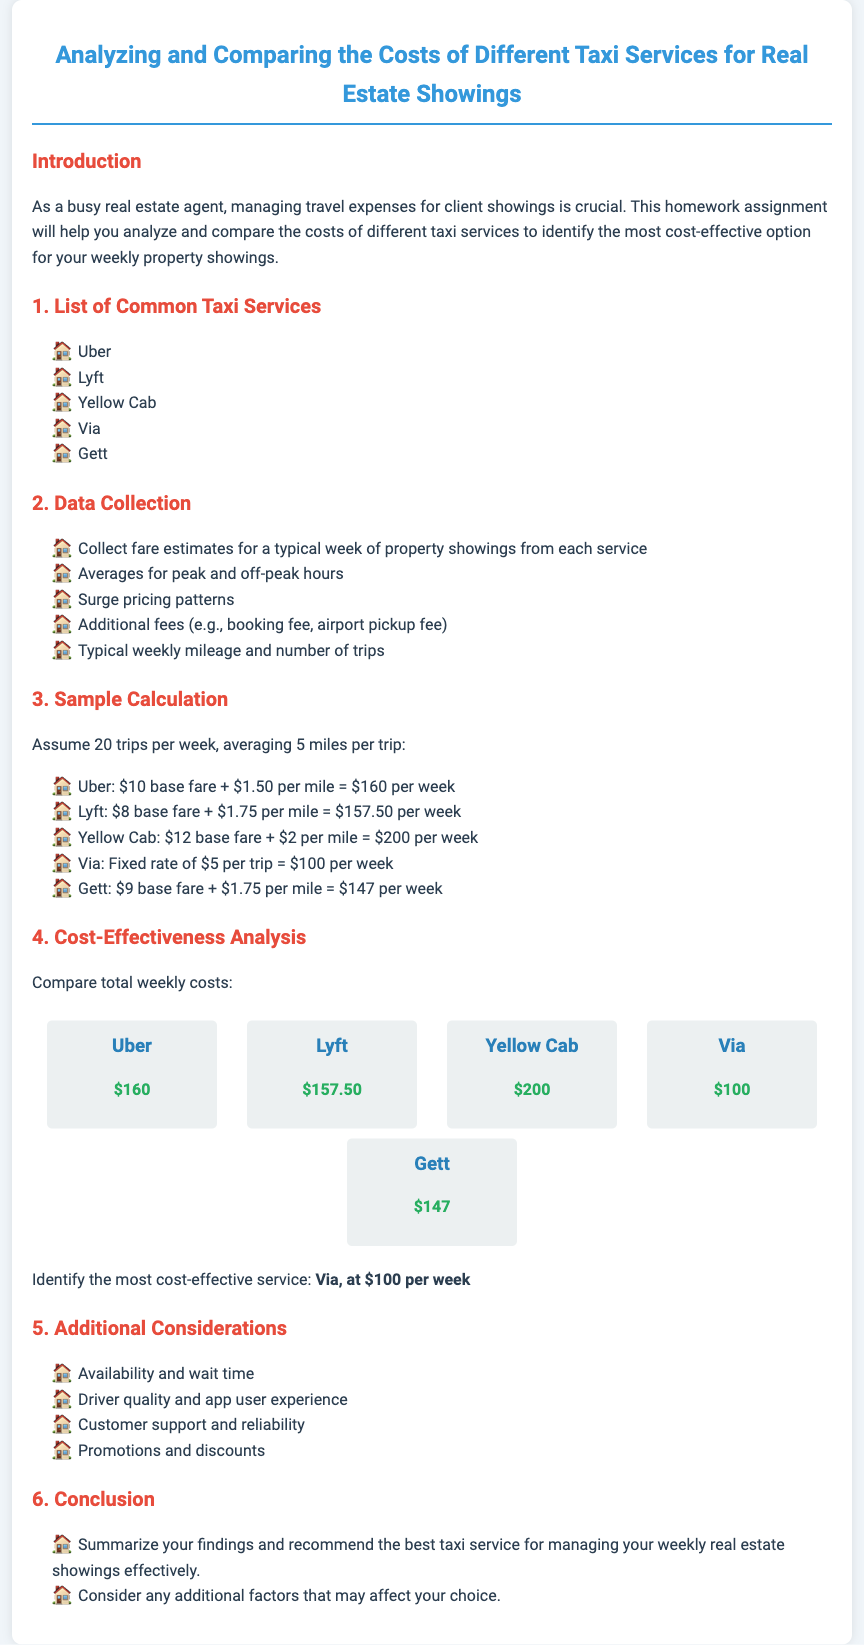what is the total cost for Uber per week? The document states that the total weekly cost for Uber is $160.
Answer: $160 which taxi service has the highest weekly cost? The cost comparison section shows that Yellow Cab has the highest weekly cost at $200.
Answer: Yellow Cab what is the fixed rate per trip for Via? The document specifies that Via has a fixed rate of $5 per trip.
Answer: $5 which service is identified as the most cost-effective option? The conclusion identifies Via as the most cost-effective service at $100 per week.
Answer: Via how many trips per week are assumed for the calculations? The sample calculation section indicates an assumption of 20 trips per week.
Answer: 20 what is the base fare for Lyft? The document states that the base fare for Lyft is $8.
Answer: $8 which taxi service offers the lowest cost per mile? Comparisons indicate Gett has a cost of $1.75 per mile, which is lower than others except Via which has a fixed rate.
Answer: Gett what additional factors should be considered when choosing a taxi service? The document lists availability, driver quality, customer support, and promotions as additional factors to consider.
Answer: Availability, driver quality, customer support, promotions what is the typical mileage assumed for each trip? The sample calculation states that each trip averages 5 miles.
Answer: 5 miles 